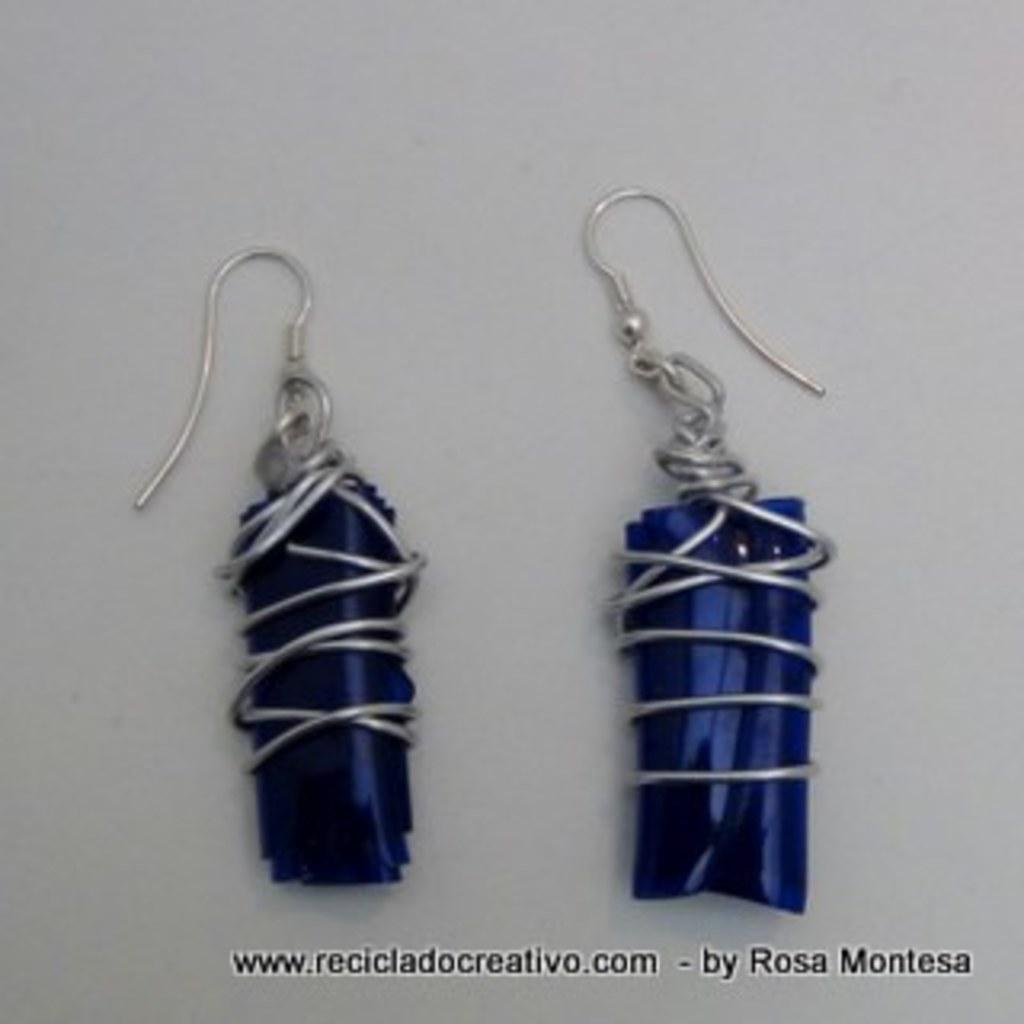In one or two sentences, can you explain what this image depicts? In this image I can see a pair of earrings and they are in blue color and I can see white color background. 